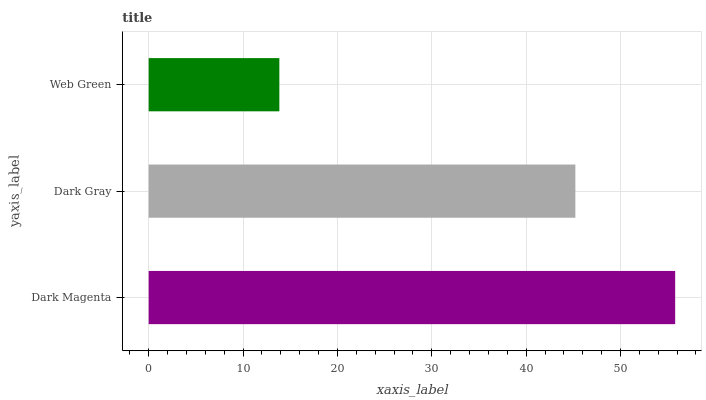Is Web Green the minimum?
Answer yes or no. Yes. Is Dark Magenta the maximum?
Answer yes or no. Yes. Is Dark Gray the minimum?
Answer yes or no. No. Is Dark Gray the maximum?
Answer yes or no. No. Is Dark Magenta greater than Dark Gray?
Answer yes or no. Yes. Is Dark Gray less than Dark Magenta?
Answer yes or no. Yes. Is Dark Gray greater than Dark Magenta?
Answer yes or no. No. Is Dark Magenta less than Dark Gray?
Answer yes or no. No. Is Dark Gray the high median?
Answer yes or no. Yes. Is Dark Gray the low median?
Answer yes or no. Yes. Is Web Green the high median?
Answer yes or no. No. Is Web Green the low median?
Answer yes or no. No. 